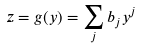<formula> <loc_0><loc_0><loc_500><loc_500>z = g ( y ) = \sum _ { j } b _ { j } y ^ { j }</formula> 